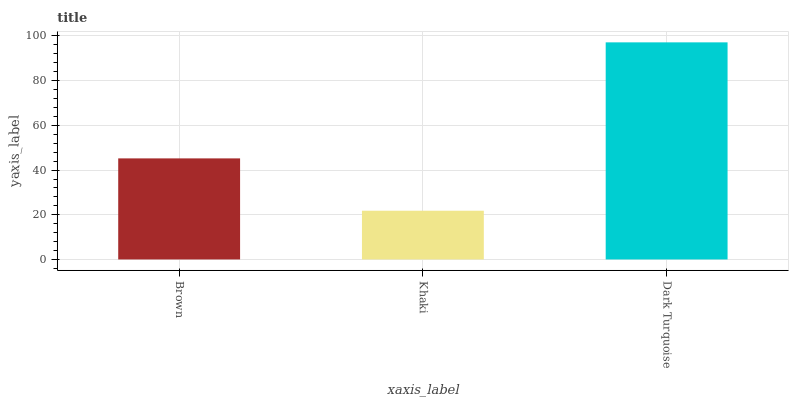Is Khaki the minimum?
Answer yes or no. Yes. Is Dark Turquoise the maximum?
Answer yes or no. Yes. Is Dark Turquoise the minimum?
Answer yes or no. No. Is Khaki the maximum?
Answer yes or no. No. Is Dark Turquoise greater than Khaki?
Answer yes or no. Yes. Is Khaki less than Dark Turquoise?
Answer yes or no. Yes. Is Khaki greater than Dark Turquoise?
Answer yes or no. No. Is Dark Turquoise less than Khaki?
Answer yes or no. No. Is Brown the high median?
Answer yes or no. Yes. Is Brown the low median?
Answer yes or no. Yes. Is Dark Turquoise the high median?
Answer yes or no. No. Is Dark Turquoise the low median?
Answer yes or no. No. 